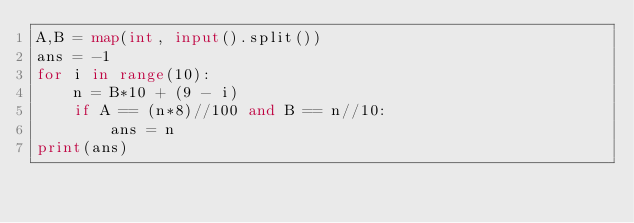<code> <loc_0><loc_0><loc_500><loc_500><_Python_>A,B = map(int, input().split())
ans = -1
for i in range(10):
    n = B*10 + (9 - i)
    if A == (n*8)//100 and B == n//10:
        ans = n
print(ans)</code> 